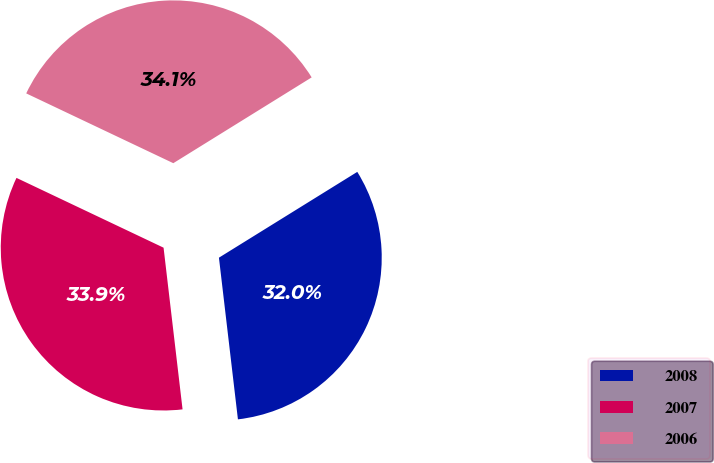<chart> <loc_0><loc_0><loc_500><loc_500><pie_chart><fcel>2008<fcel>2007<fcel>2006<nl><fcel>31.97%<fcel>33.91%<fcel>34.11%<nl></chart> 